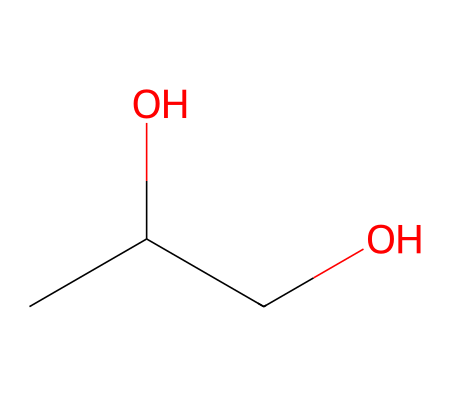What is the molecular formula of propylene glycol? The SMILES representation shows that there are three carbon atoms (C), eight hydrogen atoms (H), and two oxygen atoms (O). By counting these components, the molecular formula is determined.
Answer: C3H8O2 How many hydroxyl (–OH) groups are present in the structure? The SMILES structure indicates there are two –OH groups (one on each of the carbon atoms shown). This can be identified by the "O" next to "C" in the representation, confirming the presence of two hydroxyl groups.
Answer: 2 Identify the functional group in propylene glycol. The compound has two hydroxyl (–OH) groups, which defines it as a diol. This refers to the functional group present based on the multiple –OH groups attached to the carbon chain.
Answer: diol What is the total number of atoms in propylene glycol? Counting the carbon (C), hydrogen (H), and oxygen (O) atoms shows that there are 3 (carbon) + 8 (hydrogen) + 2 (oxygen) = 13 total atoms in this molecule.
Answer: 13 Based on its structure, is propylene glycol polar or nonpolar? The presence of two hydroxyl groups and their ability to form hydrogen bonds indicates that this chemical is polar. The oxygen atoms in the –OH groups contribute to this polarity.
Answer: polar What type of chemical is propylene glycol considered? Given its use as a preservative and its structure with hydroxyl groups, propylene glycol falls under the category of alcohols or specifically, glycols; these are common in food preservation and flavor enhancement.
Answer: alcohol 